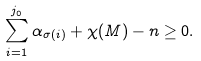<formula> <loc_0><loc_0><loc_500><loc_500>\sum _ { i = 1 } ^ { j _ { 0 } } \alpha _ { \sigma ( i ) } + \chi ( M ) - n \geq 0 .</formula> 